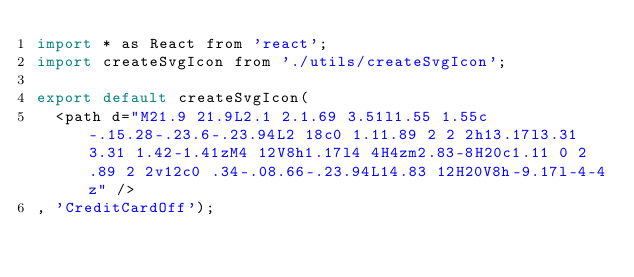<code> <loc_0><loc_0><loc_500><loc_500><_JavaScript_>import * as React from 'react';
import createSvgIcon from './utils/createSvgIcon';

export default createSvgIcon(
  <path d="M21.9 21.9L2.1 2.1.69 3.51l1.55 1.55c-.15.28-.23.6-.23.94L2 18c0 1.11.89 2 2 2h13.17l3.31 3.31 1.42-1.41zM4 12V8h1.17l4 4H4zm2.83-8H20c1.11 0 2 .89 2 2v12c0 .34-.08.66-.23.94L14.83 12H20V8h-9.17l-4-4z" />
, 'CreditCardOff');
</code> 